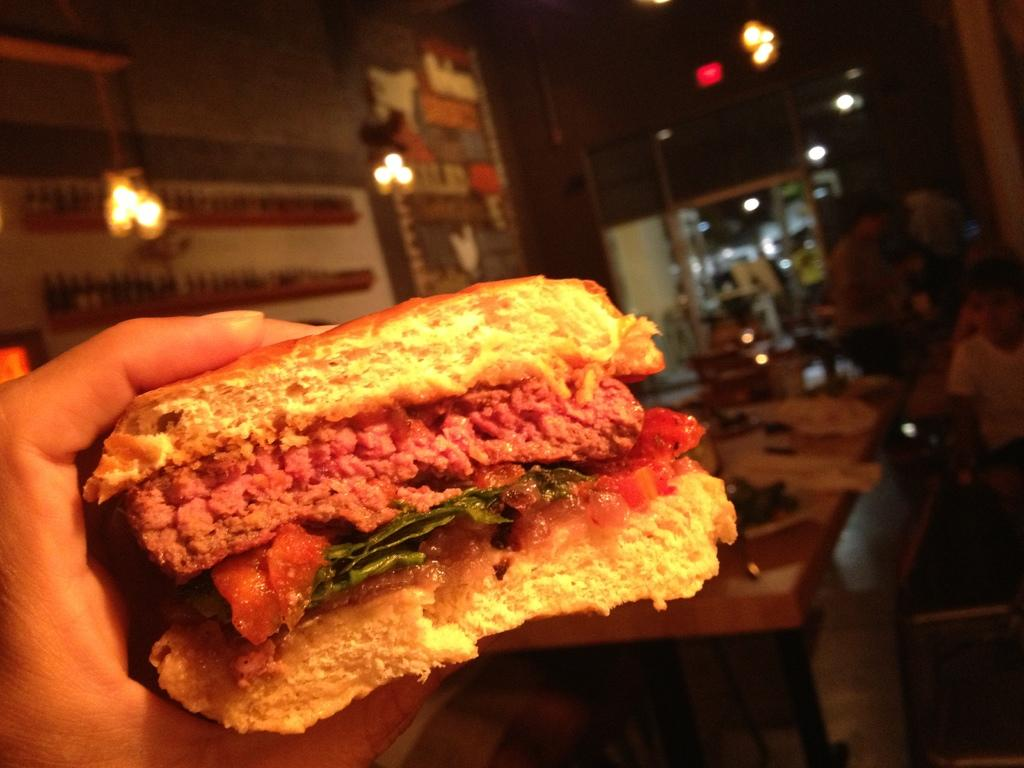What is the hand holding in the image? There is a hand holding a burger in the image. What can be seen in the background of the image? There is a table and a wall with paintings in the background of the image. What is on the wall in the background of the image? There are lights on the wall in the background of the image. Are there any people visible in the image? Yes, there are people standing near the wall in the background of the image. What type of sponge is being used by the police on their journey in the image? There is no sponge, police, or journey present in the image. 